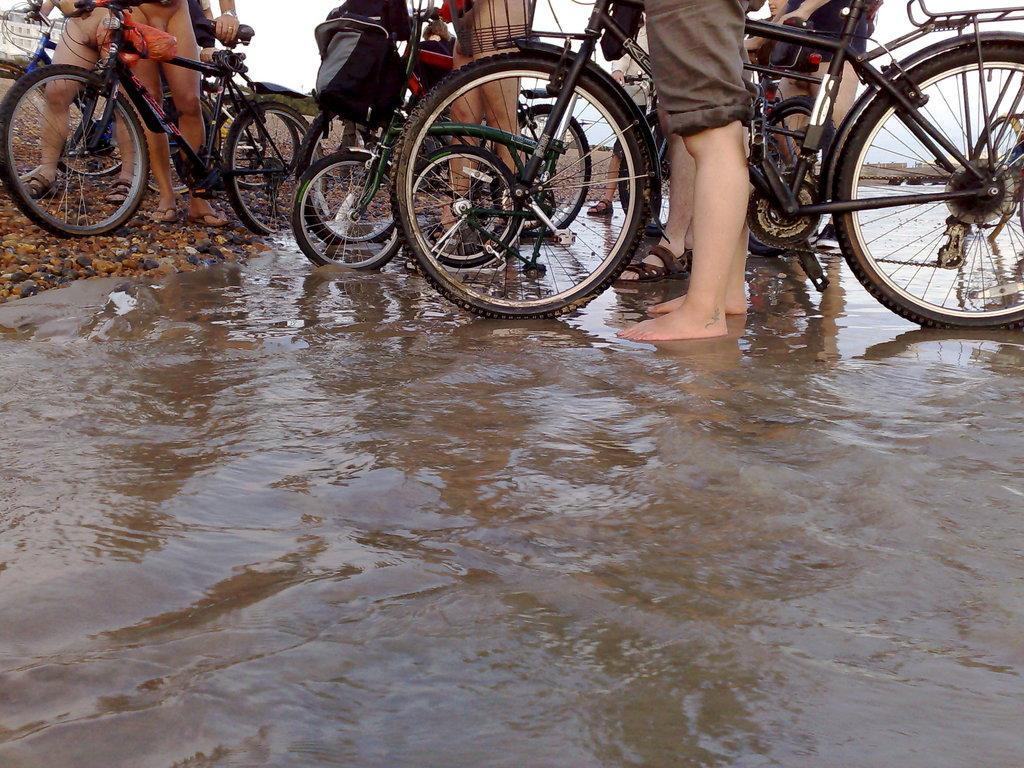How would you summarize this image in a sentence or two? In this image we can see persons holding bicycles and some are standing on the ground and some are standing on the water. In the background we can see sky. 